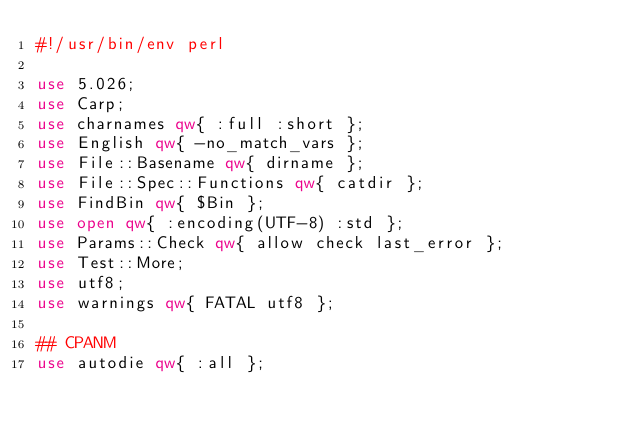Convert code to text. <code><loc_0><loc_0><loc_500><loc_500><_Perl_>#!/usr/bin/env perl

use 5.026;
use Carp;
use charnames qw{ :full :short };
use English qw{ -no_match_vars };
use File::Basename qw{ dirname };
use File::Spec::Functions qw{ catdir };
use FindBin qw{ $Bin };
use open qw{ :encoding(UTF-8) :std };
use Params::Check qw{ allow check last_error };
use Test::More;
use utf8;
use warnings qw{ FATAL utf8 };

## CPANM
use autodie qw{ :all };</code> 